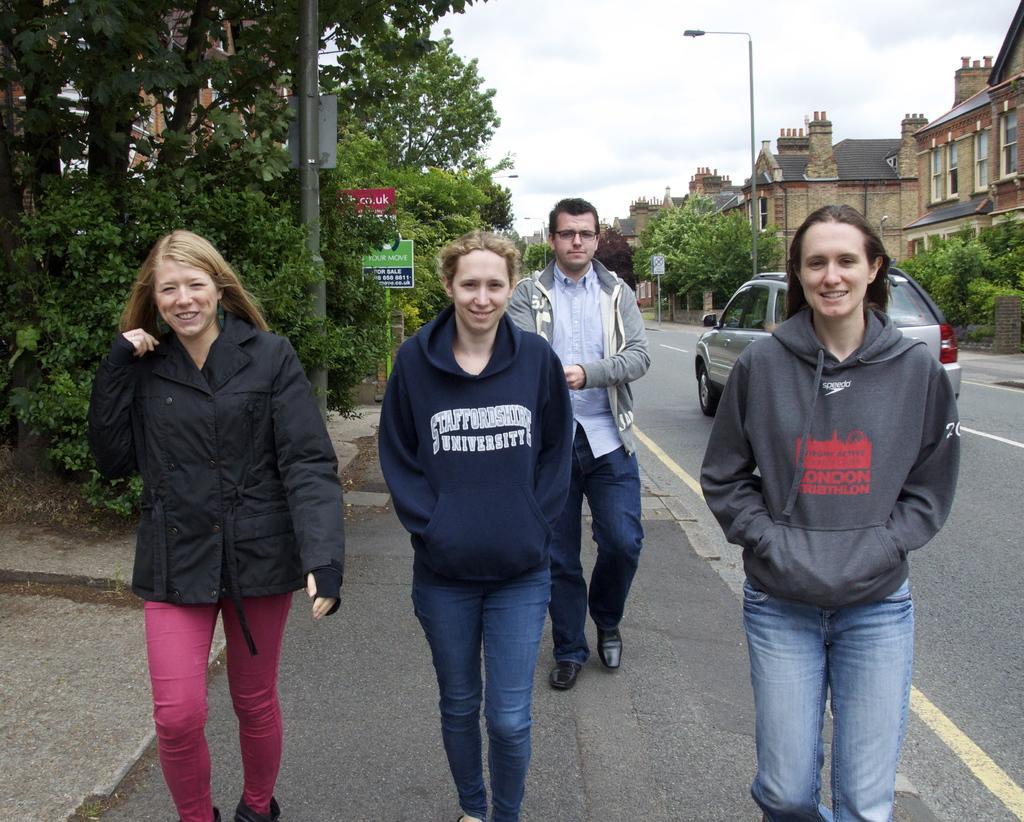In one or two sentences, can you explain what this image depicts? In this image we can see few persons on the road. In the background we can see a vehicle on the road, trees, boards on a pole, buildings, windows and clouds in the sky. 